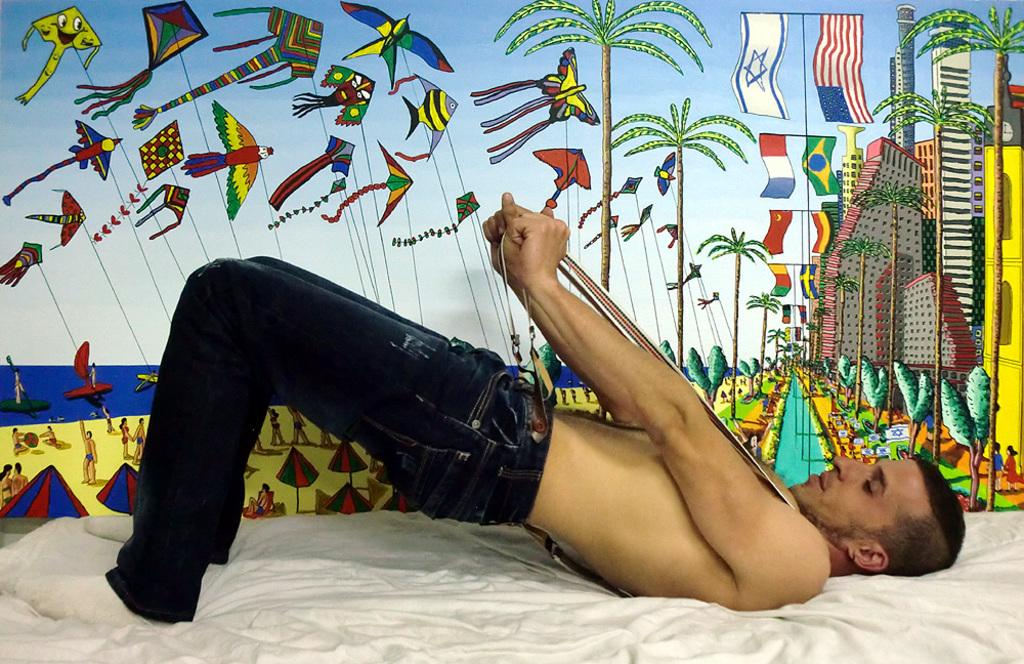What is the person in the image doing? The person is on a bed. What is the person holding in the image? The person is holding a belt. What can be seen in the background of the image? There is a wall in the background of the image. What is depicted in the painting on the wall? The painting includes kites, birds, flags, buildings, trees, and people. What else is included in the painting? The painting includes many other things, such as tents. Is the person in the image crying while holding a dog? There is no dog present in the image, and the person is not crying. 